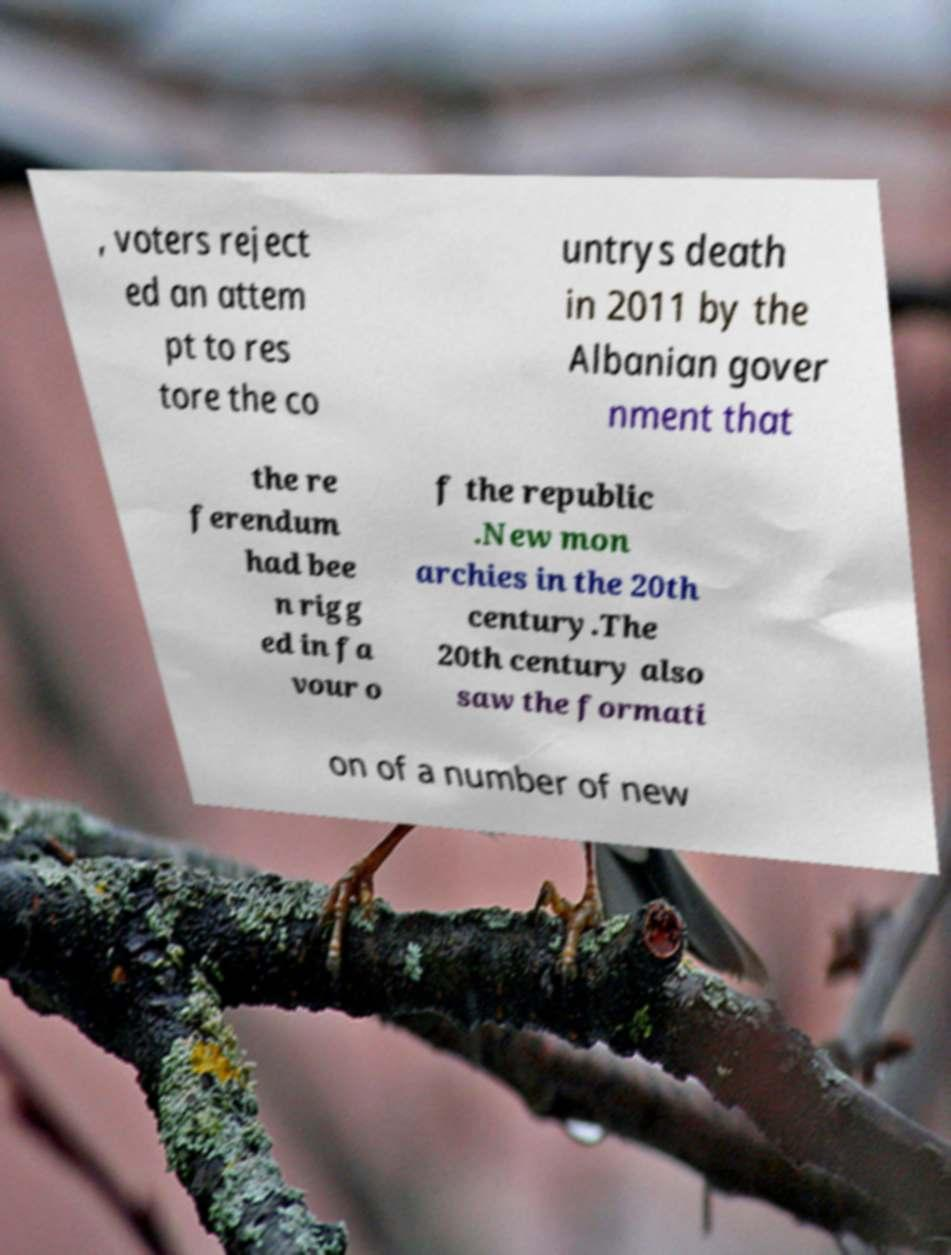There's text embedded in this image that I need extracted. Can you transcribe it verbatim? , voters reject ed an attem pt to res tore the co untrys death in 2011 by the Albanian gover nment that the re ferendum had bee n rigg ed in fa vour o f the republic .New mon archies in the 20th century.The 20th century also saw the formati on of a number of new 